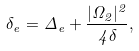Convert formula to latex. <formula><loc_0><loc_0><loc_500><loc_500>\delta _ { e } = \Delta _ { e } + \frac { | \Omega _ { 2 } | ^ { 2 } } { 4 \delta } ,</formula> 